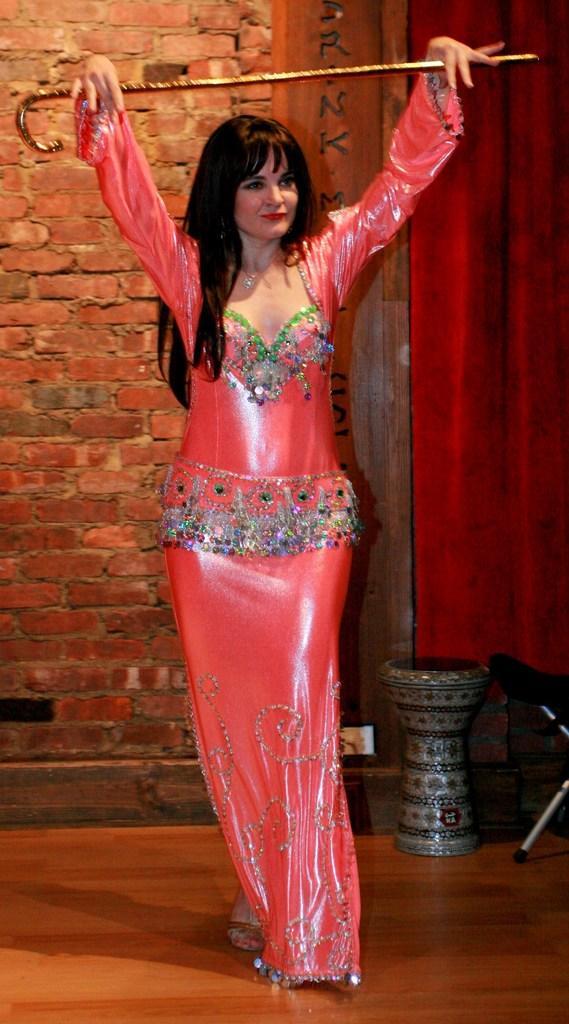In one or two sentences, can you explain what this image depicts? In this image I see a woman who is wearing orange color dress and I see that she is holding a stick in her hands and I see the platform. In the background I see the wall and I see the red color curtain over here. 